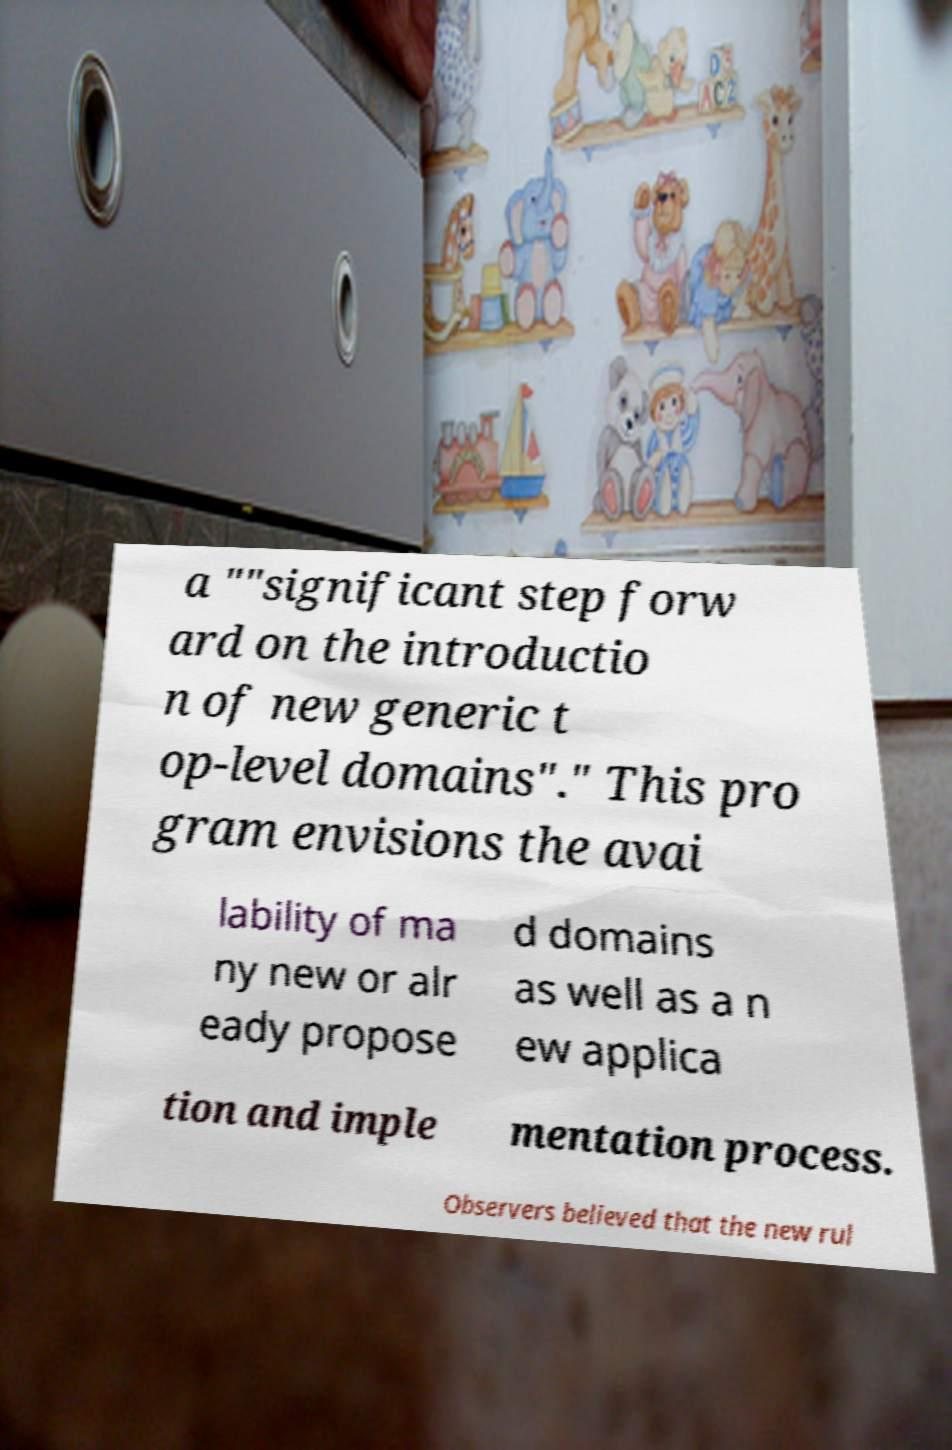Could you assist in decoding the text presented in this image and type it out clearly? a ""significant step forw ard on the introductio n of new generic t op-level domains"." This pro gram envisions the avai lability of ma ny new or alr eady propose d domains as well as a n ew applica tion and imple mentation process. Observers believed that the new rul 